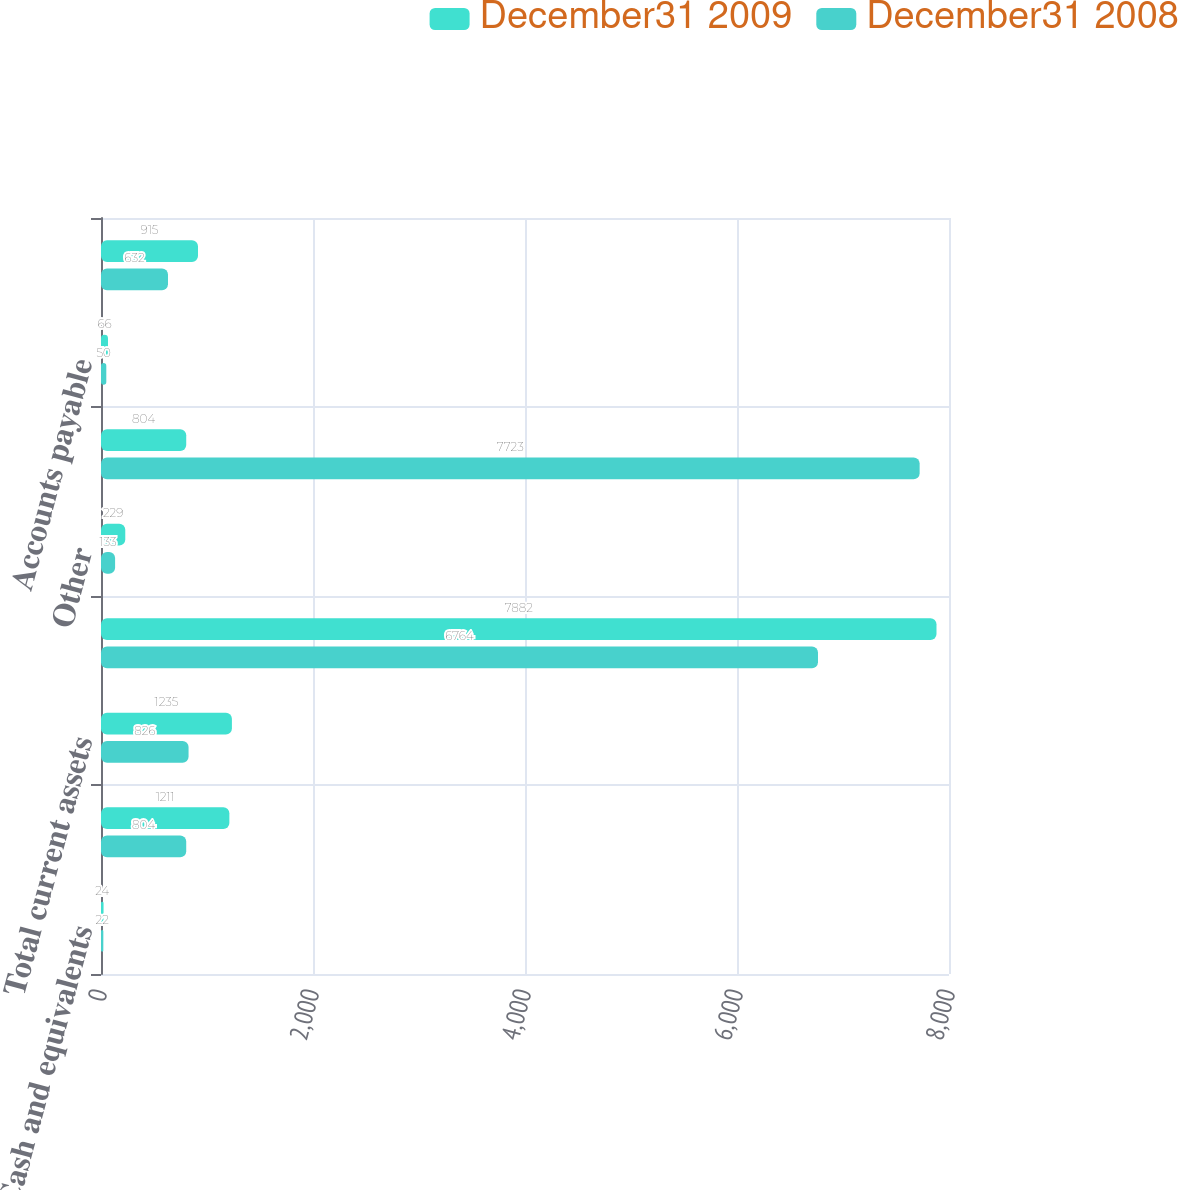Convert chart to OTSL. <chart><loc_0><loc_0><loc_500><loc_500><stacked_bar_chart><ecel><fcel>Cash and equivalents<fcel>Accounts and notes receivable<fcel>Total current assets<fcel>Investments in subsidiaries<fcel>Other<fcel>Total assets<fcel>Accounts payable<fcel>Other current liabilities<nl><fcel>December31 2009<fcel>24<fcel>1211<fcel>1235<fcel>7882<fcel>229<fcel>804<fcel>66<fcel>915<nl><fcel>December31 2008<fcel>22<fcel>804<fcel>826<fcel>6764<fcel>133<fcel>7723<fcel>50<fcel>632<nl></chart> 